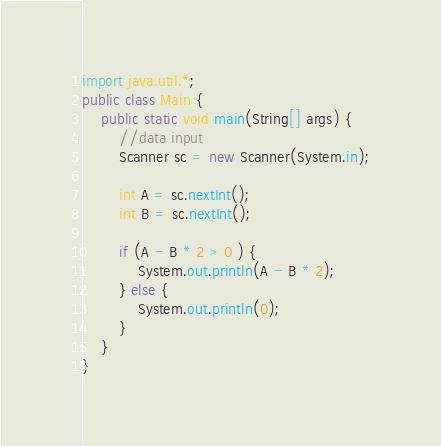Convert code to text. <code><loc_0><loc_0><loc_500><loc_500><_Java_>import java.util.*;
public class Main {
    public static void main(String[] args) {
        //data input
        Scanner sc = new Scanner(System.in);

        int A = sc.nextInt();
        int B = sc.nextInt();

        if (A - B * 2 > 0 ) {
            System.out.println(A - B * 2);
        } else {
            System.out.println(0);
        }
    }
}</code> 